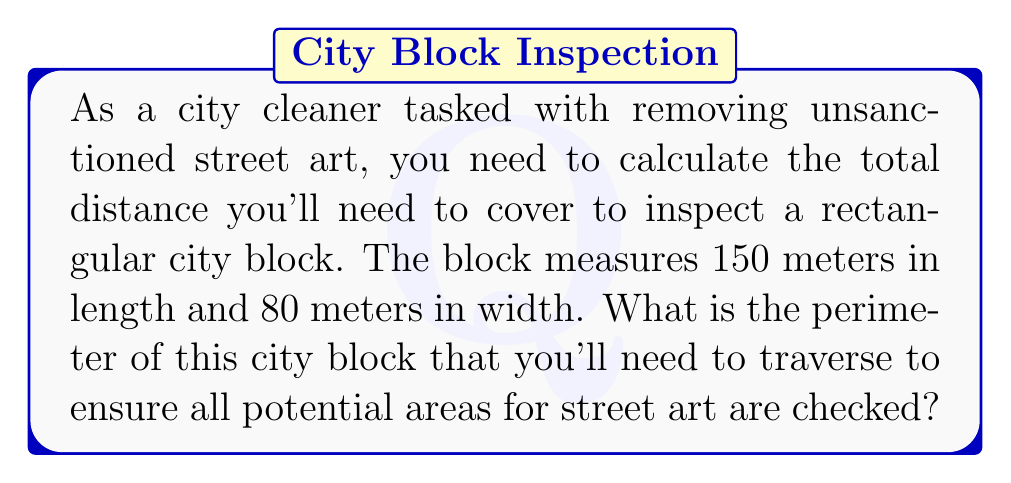Can you solve this math problem? To solve this problem, we need to calculate the perimeter of a rectangle. The perimeter is the distance around the entire shape, which is the sum of all its sides.

For a rectangle, the formula for perimeter is:

$$P = 2l + 2w$$

Where:
$P$ = perimeter
$l$ = length
$w$ = width

Given:
$l = 150$ meters
$w = 80$ meters

Let's substitute these values into the formula:

$$\begin{align*}
P &= 2(150) + 2(80) \\
&= 300 + 160 \\
&= 460
\end{align*}$$

Therefore, the perimeter of the city block is 460 meters.

[asy]
unitsize(0.02cm);
draw((0,0)--(150,0)--(150,80)--(0,80)--cycle);
label("150 m", (75,-10));
label("80 m", (-10,40), W);
label("City Block", (75,40));
[/asy]
Answer: The perimeter of the city block is 460 meters. 